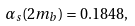Convert formula to latex. <formula><loc_0><loc_0><loc_500><loc_500>\alpha _ { s } ( 2 m _ { b } ) = 0 . 1 8 4 8 ,</formula> 